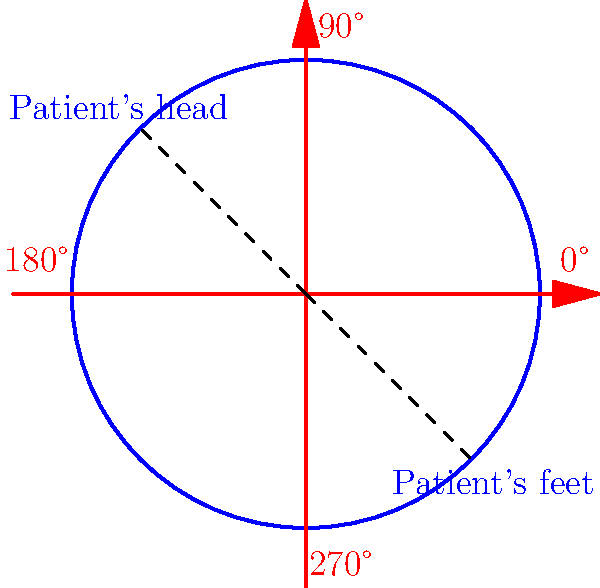A massage table can be rotated in 90° increments. If a patient is initially positioned with their head at the 135° position and their feet at the 315° position, how many 90° clockwise rotations are needed to align the patient's head with the 45° position? Let's approach this step-by-step:

1) The rotation group of the massage table consists of four elements: 0°, 90°, 180°, and 270° clockwise rotations.

2) The patient's initial position:
   - Head at 135°
   - Feet at 315°

3) The desired final position:
   - Head at 45°
   - Feet at 225° (opposite to the head)

4) To find the number of 90° clockwise rotations needed, we can calculate how many 90° steps it takes to move from 135° to 45°:

   135° → 45° → 315° → 225° → 135° → 45°

5) Counting the steps:
   - 135° to 45°: 1 step
   - 45° to 315°: 2 steps
   - 315° to 225°: 3 steps
   - 225° to 135°: 4 steps
   - 135° to 45°: 5 steps

6) Therefore, it takes 5 rotations of 90° each to move the patient's head from 135° to 45°.
Answer: 5 rotations 